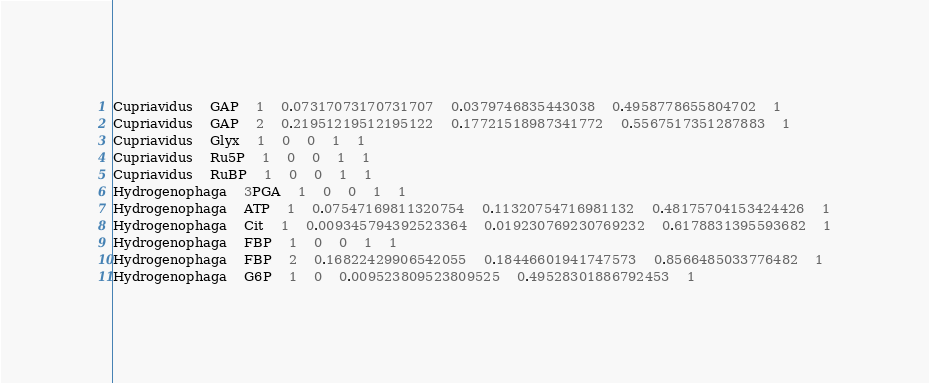Convert code to text. <code><loc_0><loc_0><loc_500><loc_500><_SQL_>Cupriavidus	GAP	1	0.07317073170731707	0.0379746835443038	0.4958778655804702	1
Cupriavidus	GAP	2	0.21951219512195122	0.17721518987341772	0.5567517351287883	1
Cupriavidus	Glyx	1	0	0	1	1
Cupriavidus	Ru5P	1	0	0	1	1
Cupriavidus	RuBP	1	0	0	1	1
Hydrogenophaga	3PGA	1	0	0	1	1
Hydrogenophaga	ATP	1	0.07547169811320754	0.11320754716981132	0.48175704153424426	1
Hydrogenophaga	Cit	1	0.009345794392523364	0.019230769230769232	0.6178831395593682	1
Hydrogenophaga	FBP	1	0	0	1	1
Hydrogenophaga	FBP	2	0.16822429906542055	0.18446601941747573	0.8566485033776482	1
Hydrogenophaga	G6P	1	0	0.009523809523809525	0.49528301886792453	1</code> 